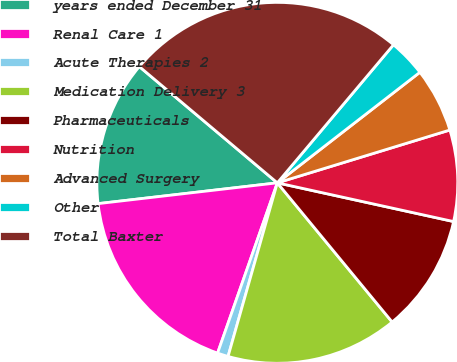Convert chart. <chart><loc_0><loc_0><loc_500><loc_500><pie_chart><fcel>years ended December 31<fcel>Renal Care 1<fcel>Acute Therapies 2<fcel>Medication Delivery 3<fcel>Pharmaceuticals<fcel>Nutrition<fcel>Advanced Surgery<fcel>Other<fcel>Total Baxter<nl><fcel>12.98%<fcel>17.79%<fcel>0.97%<fcel>15.38%<fcel>10.58%<fcel>8.17%<fcel>5.77%<fcel>3.37%<fcel>24.99%<nl></chart> 